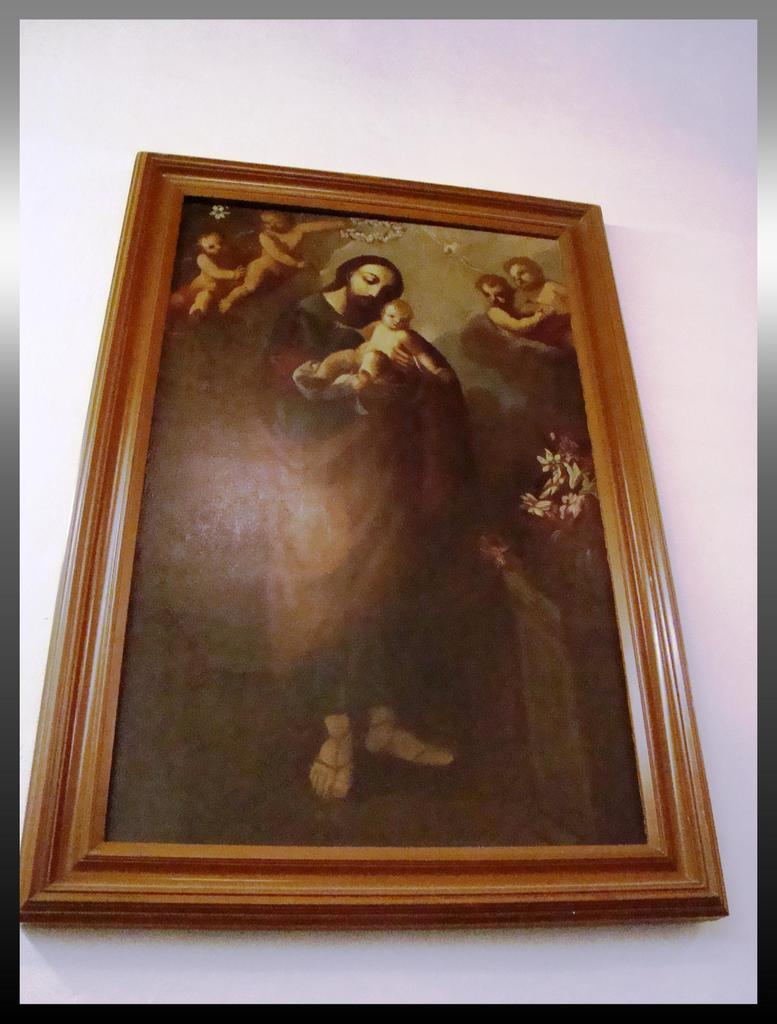What object is present in the image that typically holds a photograph? There is a photo frame in the image. What is the color of the surface on which the photo frame is placed? The photo frame is on a white surface. What can be seen in the photograph inside the frame? The photo in the frame contains a picture of Jesus and people. How many basketballs are visible in the image? There are no basketballs present in the image. What type of quilt is being used to cover the people in the photo? The photo in the frame contains a picture of Jesus and people, but there is no mention of a quilt or any covering. 